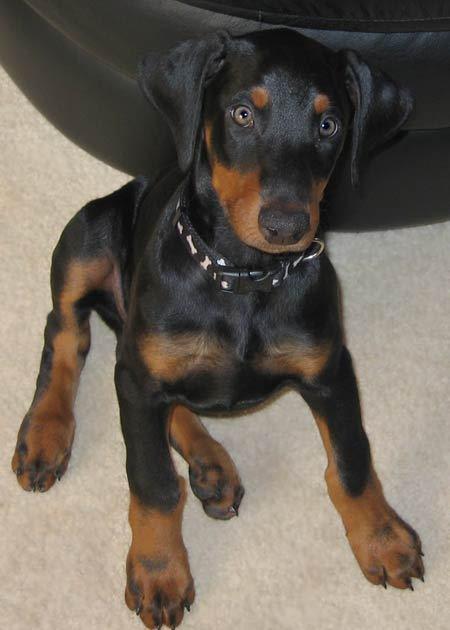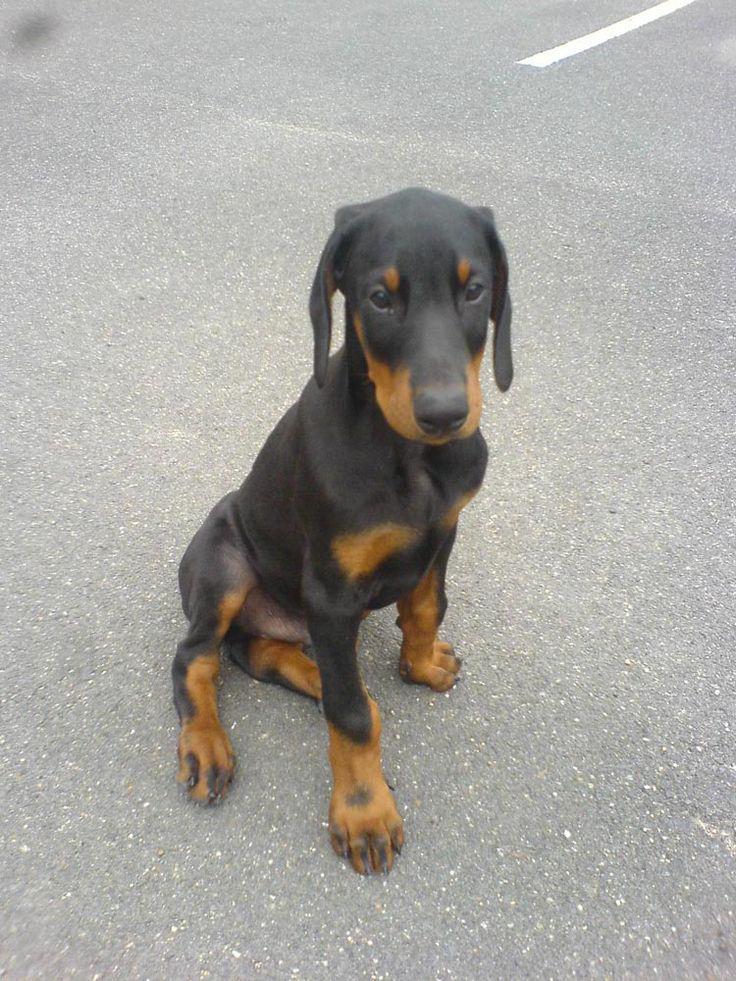The first image is the image on the left, the second image is the image on the right. Evaluate the accuracy of this statement regarding the images: "There are more dogs in the image on the right.". Is it true? Answer yes or no. No. The first image is the image on the left, the second image is the image on the right. Examine the images to the left and right. Is the description "The left and right image contains the same number of dogs." accurate? Answer yes or no. Yes. 